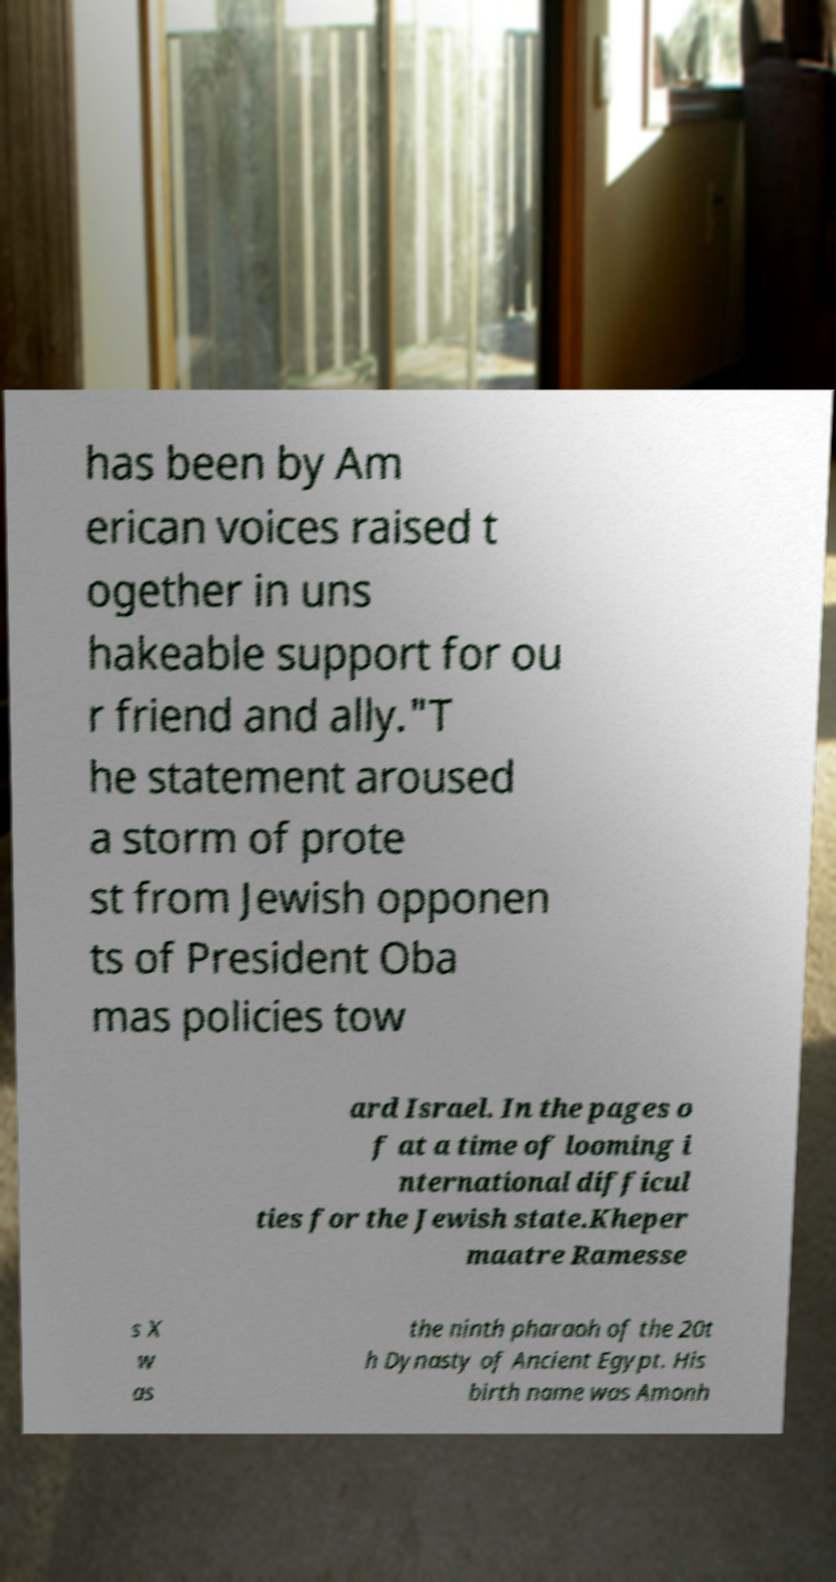Could you assist in decoding the text presented in this image and type it out clearly? has been by Am erican voices raised t ogether in uns hakeable support for ou r friend and ally."T he statement aroused a storm of prote st from Jewish opponen ts of President Oba mas policies tow ard Israel. In the pages o f at a time of looming i nternational difficul ties for the Jewish state.Kheper maatre Ramesse s X w as the ninth pharaoh of the 20t h Dynasty of Ancient Egypt. His birth name was Amonh 